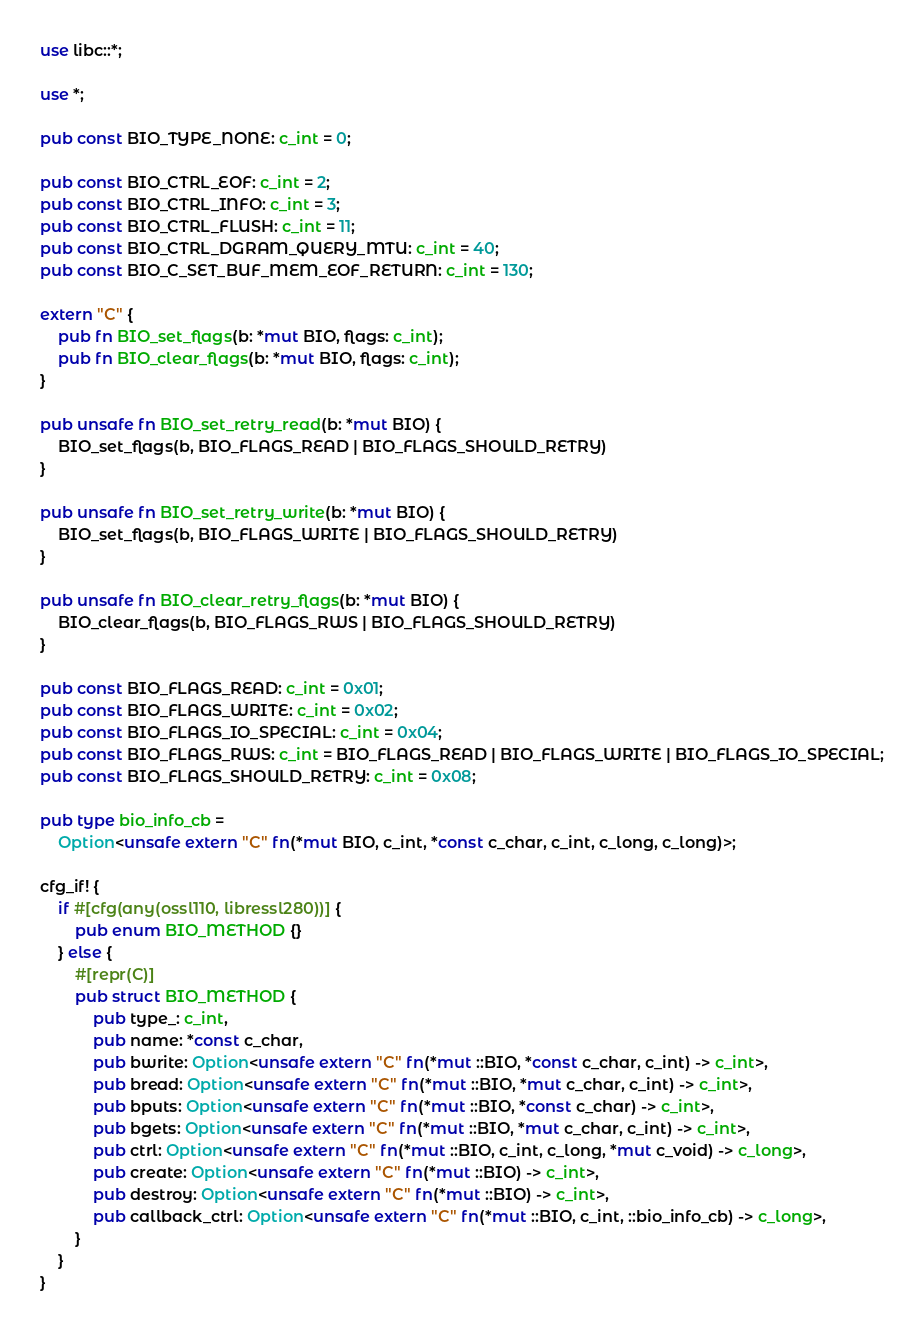Convert code to text. <code><loc_0><loc_0><loc_500><loc_500><_Rust_>use libc::*;

use *;

pub const BIO_TYPE_NONE: c_int = 0;

pub const BIO_CTRL_EOF: c_int = 2;
pub const BIO_CTRL_INFO: c_int = 3;
pub const BIO_CTRL_FLUSH: c_int = 11;
pub const BIO_CTRL_DGRAM_QUERY_MTU: c_int = 40;
pub const BIO_C_SET_BUF_MEM_EOF_RETURN: c_int = 130;

extern "C" {
    pub fn BIO_set_flags(b: *mut BIO, flags: c_int);
    pub fn BIO_clear_flags(b: *mut BIO, flags: c_int);
}

pub unsafe fn BIO_set_retry_read(b: *mut BIO) {
    BIO_set_flags(b, BIO_FLAGS_READ | BIO_FLAGS_SHOULD_RETRY)
}

pub unsafe fn BIO_set_retry_write(b: *mut BIO) {
    BIO_set_flags(b, BIO_FLAGS_WRITE | BIO_FLAGS_SHOULD_RETRY)
}

pub unsafe fn BIO_clear_retry_flags(b: *mut BIO) {
    BIO_clear_flags(b, BIO_FLAGS_RWS | BIO_FLAGS_SHOULD_RETRY)
}

pub const BIO_FLAGS_READ: c_int = 0x01;
pub const BIO_FLAGS_WRITE: c_int = 0x02;
pub const BIO_FLAGS_IO_SPECIAL: c_int = 0x04;
pub const BIO_FLAGS_RWS: c_int = BIO_FLAGS_READ | BIO_FLAGS_WRITE | BIO_FLAGS_IO_SPECIAL;
pub const BIO_FLAGS_SHOULD_RETRY: c_int = 0x08;

pub type bio_info_cb =
    Option<unsafe extern "C" fn(*mut BIO, c_int, *const c_char, c_int, c_long, c_long)>;

cfg_if! {
    if #[cfg(any(ossl110, libressl280))] {
        pub enum BIO_METHOD {}
    } else {
        #[repr(C)]
        pub struct BIO_METHOD {
            pub type_: c_int,
            pub name: *const c_char,
            pub bwrite: Option<unsafe extern "C" fn(*mut ::BIO, *const c_char, c_int) -> c_int>,
            pub bread: Option<unsafe extern "C" fn(*mut ::BIO, *mut c_char, c_int) -> c_int>,
            pub bputs: Option<unsafe extern "C" fn(*mut ::BIO, *const c_char) -> c_int>,
            pub bgets: Option<unsafe extern "C" fn(*mut ::BIO, *mut c_char, c_int) -> c_int>,
            pub ctrl: Option<unsafe extern "C" fn(*mut ::BIO, c_int, c_long, *mut c_void) -> c_long>,
            pub create: Option<unsafe extern "C" fn(*mut ::BIO) -> c_int>,
            pub destroy: Option<unsafe extern "C" fn(*mut ::BIO) -> c_int>,
            pub callback_ctrl: Option<unsafe extern "C" fn(*mut ::BIO, c_int, ::bio_info_cb) -> c_long>,
        }
    }
}
</code> 